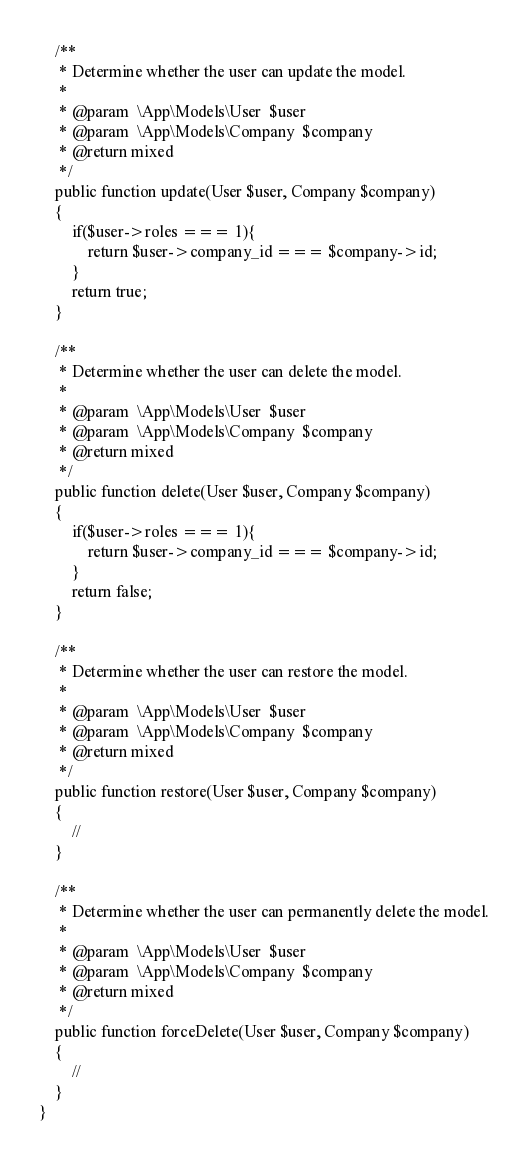Convert code to text. <code><loc_0><loc_0><loc_500><loc_500><_PHP_>    /**
     * Determine whether the user can update the model.
     *
     * @param  \App\Models\User  $user
     * @param  \App\Models\Company  $company
     * @return mixed
     */
    public function update(User $user, Company $company)
    {
        if($user->roles === 1){
            return $user->company_id === $company->id;
        }
        return true;
    }

    /**
     * Determine whether the user can delete the model.
     *
     * @param  \App\Models\User  $user
     * @param  \App\Models\Company  $company
     * @return mixed
     */
    public function delete(User $user, Company $company)
    {
        if($user->roles === 1){
            return $user->company_id === $company->id;
        }
        return false;
    }

    /**
     * Determine whether the user can restore the model.
     *
     * @param  \App\Models\User  $user
     * @param  \App\Models\Company  $company
     * @return mixed
     */
    public function restore(User $user, Company $company)
    {
        //
    }

    /**
     * Determine whether the user can permanently delete the model.
     *
     * @param  \App\Models\User  $user
     * @param  \App\Models\Company  $company
     * @return mixed
     */
    public function forceDelete(User $user, Company $company)
    {
        //
    }
}
</code> 